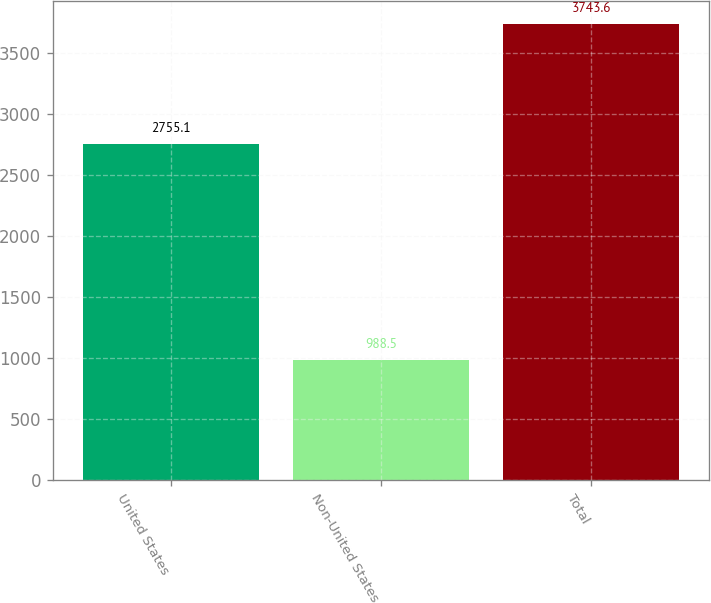Convert chart. <chart><loc_0><loc_0><loc_500><loc_500><bar_chart><fcel>United States<fcel>Non-United States<fcel>Total<nl><fcel>2755.1<fcel>988.5<fcel>3743.6<nl></chart> 